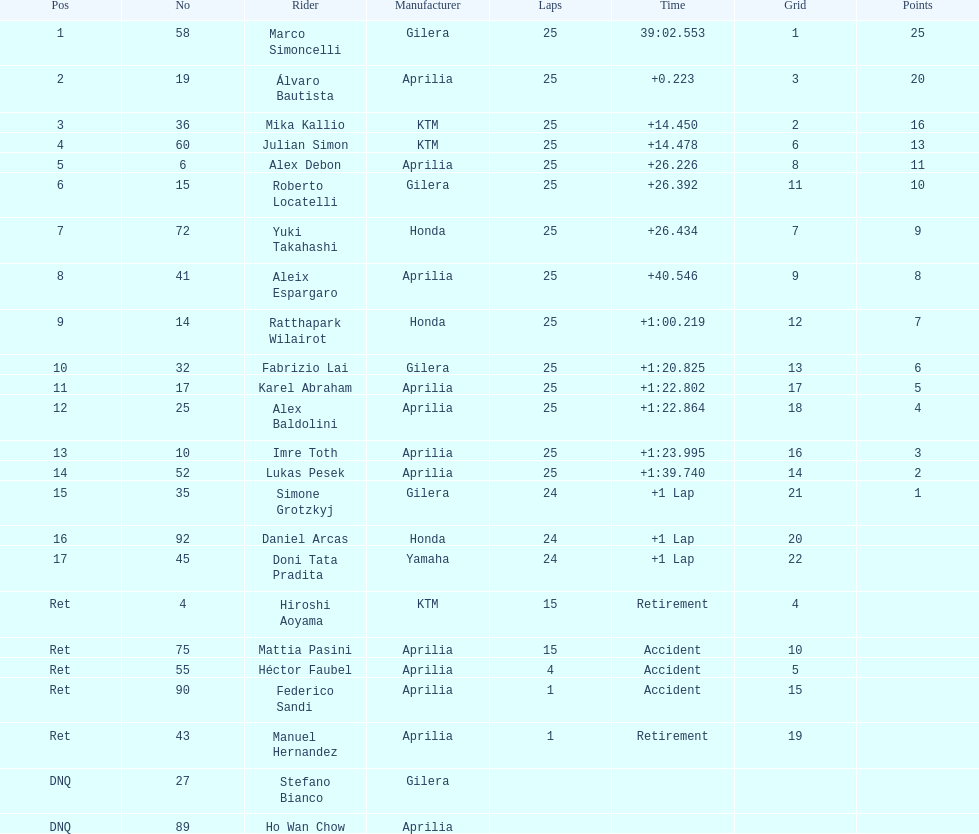Who perfomed the most number of laps, marco simoncelli or hiroshi aoyama? Marco Simoncelli. 